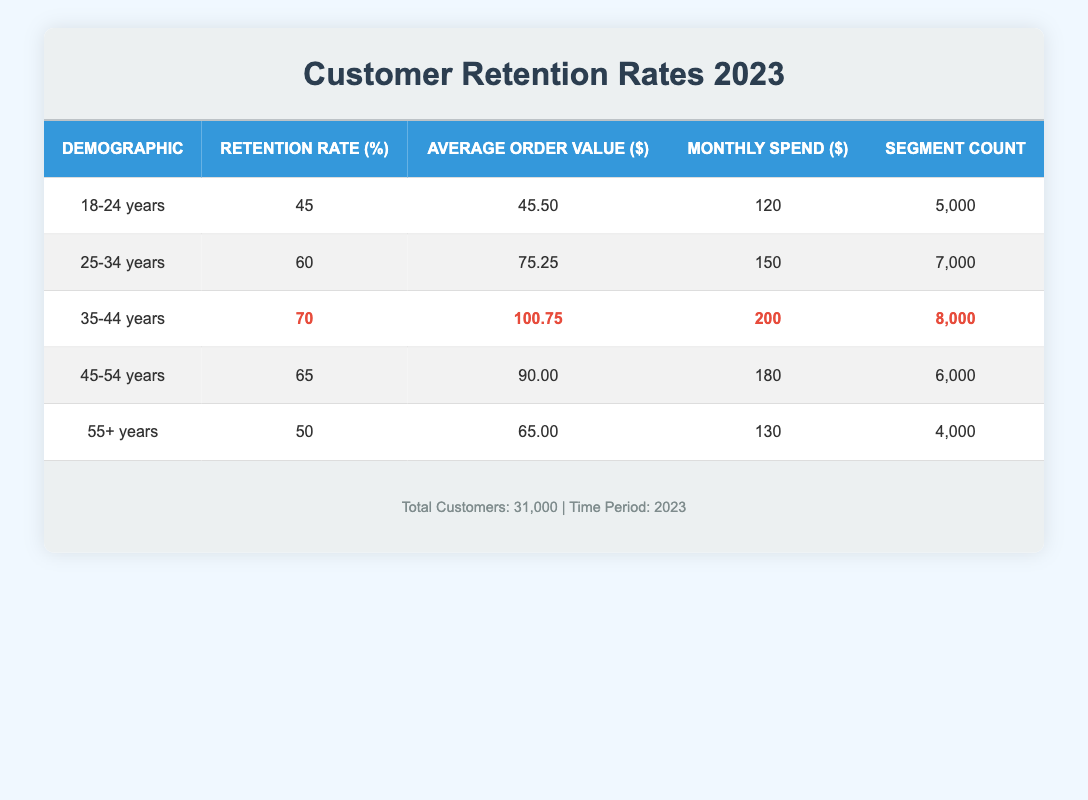What is the retention rate for the 25-34 years demographic? The table shows a specific row for the 25-34 years demographic. The retention rate listed in that row is 60%.
Answer: 60 Which demographic has the highest average order value? By looking at the average order value for each demographic: 45.50 (18-24), 75.25 (25-34), 100.75 (35-44), 90.00 (45-54), and 65.00 (55+), it is clear that the 35-44 years demographic has the highest average order value of 100.75.
Answer: 35-44 years What is the total retention rate for all demographics combined? To find the overall retention rate, sum the retention rates of all demographics: 45 + 60 + 70 + 65 + 50 = 290. Then divide by the number of demographics (5): 290 / 5 = 58. Therefore, the total retention rate across all demographics is 58%.
Answer: 58 Is the retention rate for the 18-24 years demographic higher than that for the 55+ years demographic? The retention rate for the 18-24 years demographic is 45%, while for the 55+ years demographic, it is 50%. Since 45% is less than 50%, the statement is false.
Answer: No What is the average monthly spend for the 35-44 years demographic? The average monthly spend for the 35-44 years demographic is clearly shown in the table as 200.
Answer: 200 Which demographic has the least number of segments, and what is the retention rate for that segment? The number of segments are as follows: 18-24 (5000), 25-34 (7000), 35-44 (8000), 45-54 (6000), and 55+ (4000). The 55+ demographic has the least segments with a count of 4000, and its retention rate is 50%.
Answer: 55+ years, 50 What is the difference in monthly spend between the 25-34 years and 45-54 years demographics? The monthly spend for 25-34 years is 150, and for 45-54 years is 180. The difference is calculated as 180 - 150 = 30.
Answer: 30 Which demographic has a retention rate greater than 60%? The demographics with retention rates greater than 60% are 35-44 years (70%) and 45-54 years (65%).
Answer: 35-44 years and 45-54 years 